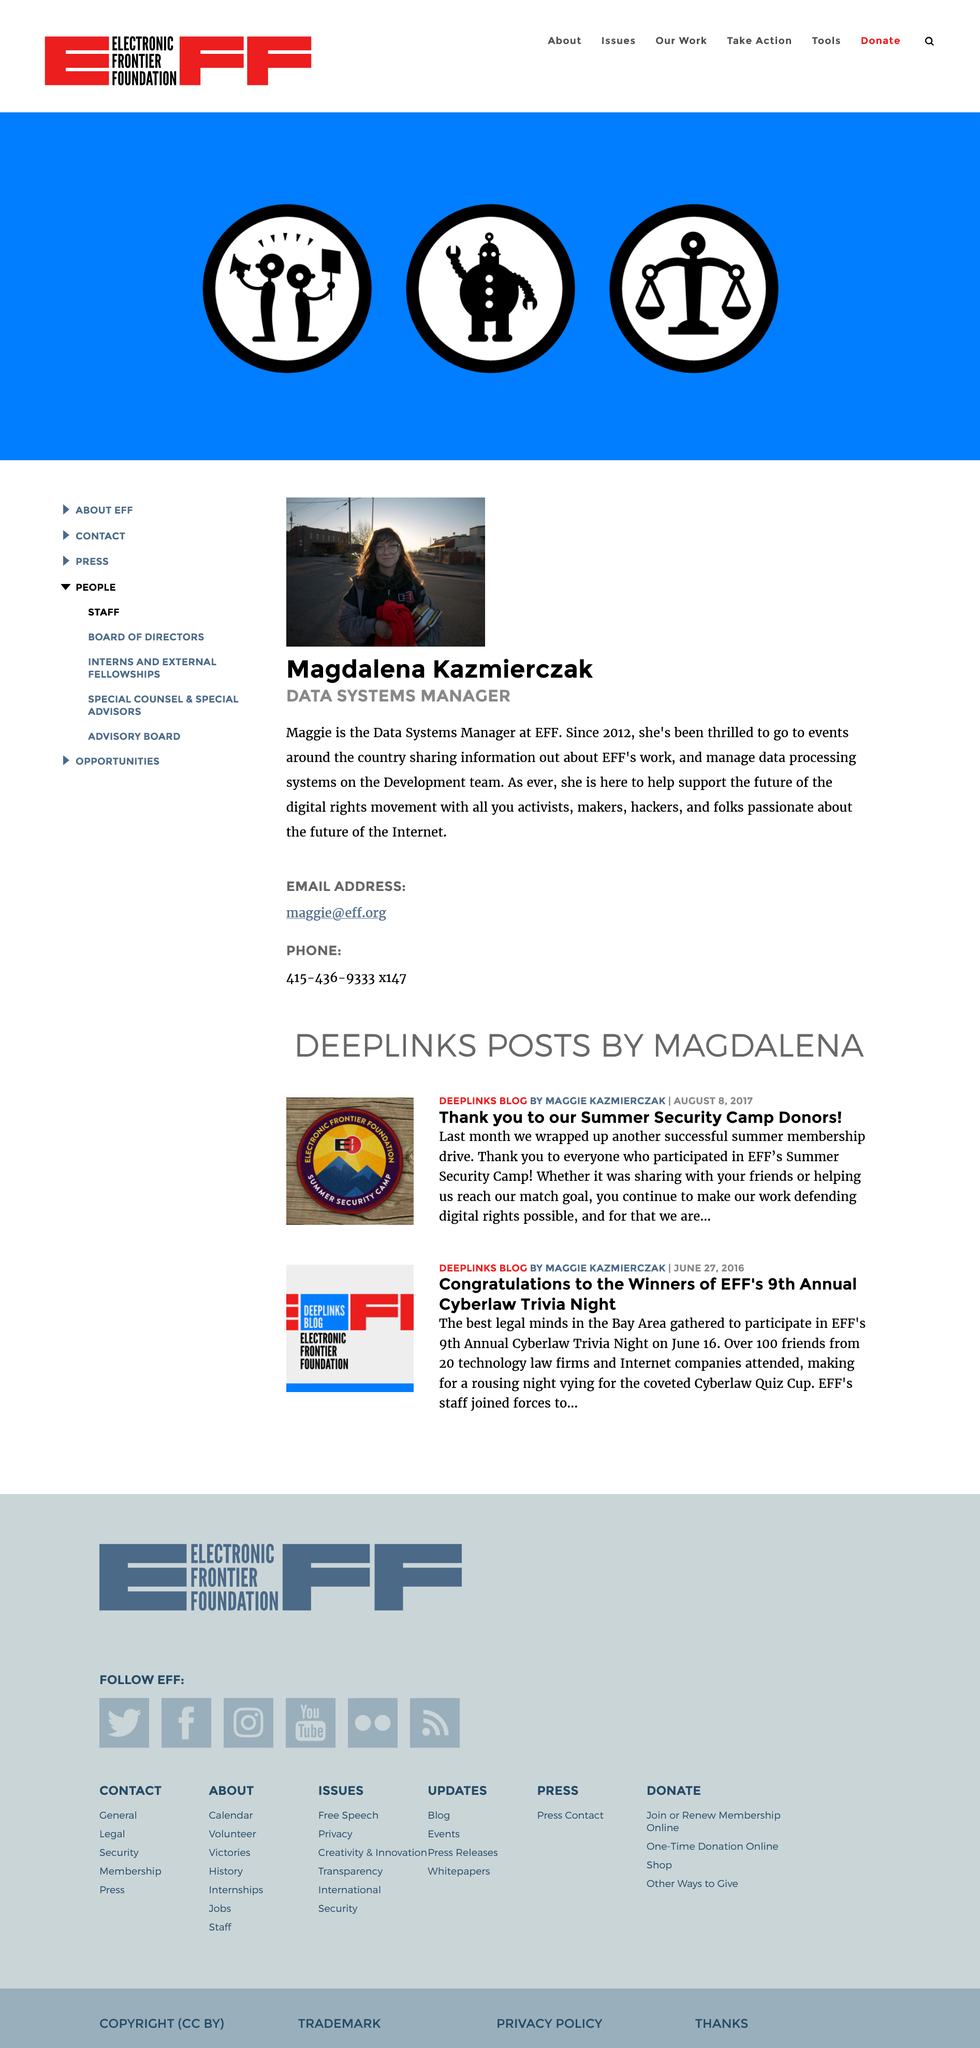Highlight a few significant elements in this photo. Magdalena Kazmierczak's email address is [maggie@eff.org](mailto:maggie@eff.org). Magdalena Kazmierczak's phone number is 415-436-9333 x147, which can be verified by any individual with access to a phone directory or a phone call. Magdalena Kazmierczak is the Data Systems Manager. 